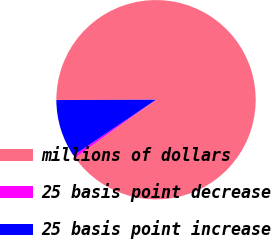Convert chart to OTSL. <chart><loc_0><loc_0><loc_500><loc_500><pie_chart><fcel>millions of dollars<fcel>25 basis point decrease<fcel>25 basis point increase<nl><fcel>90.14%<fcel>0.44%<fcel>9.41%<nl></chart> 